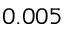Convert formula to latex. <formula><loc_0><loc_0><loc_500><loc_500>0 . 0 0 5</formula> 